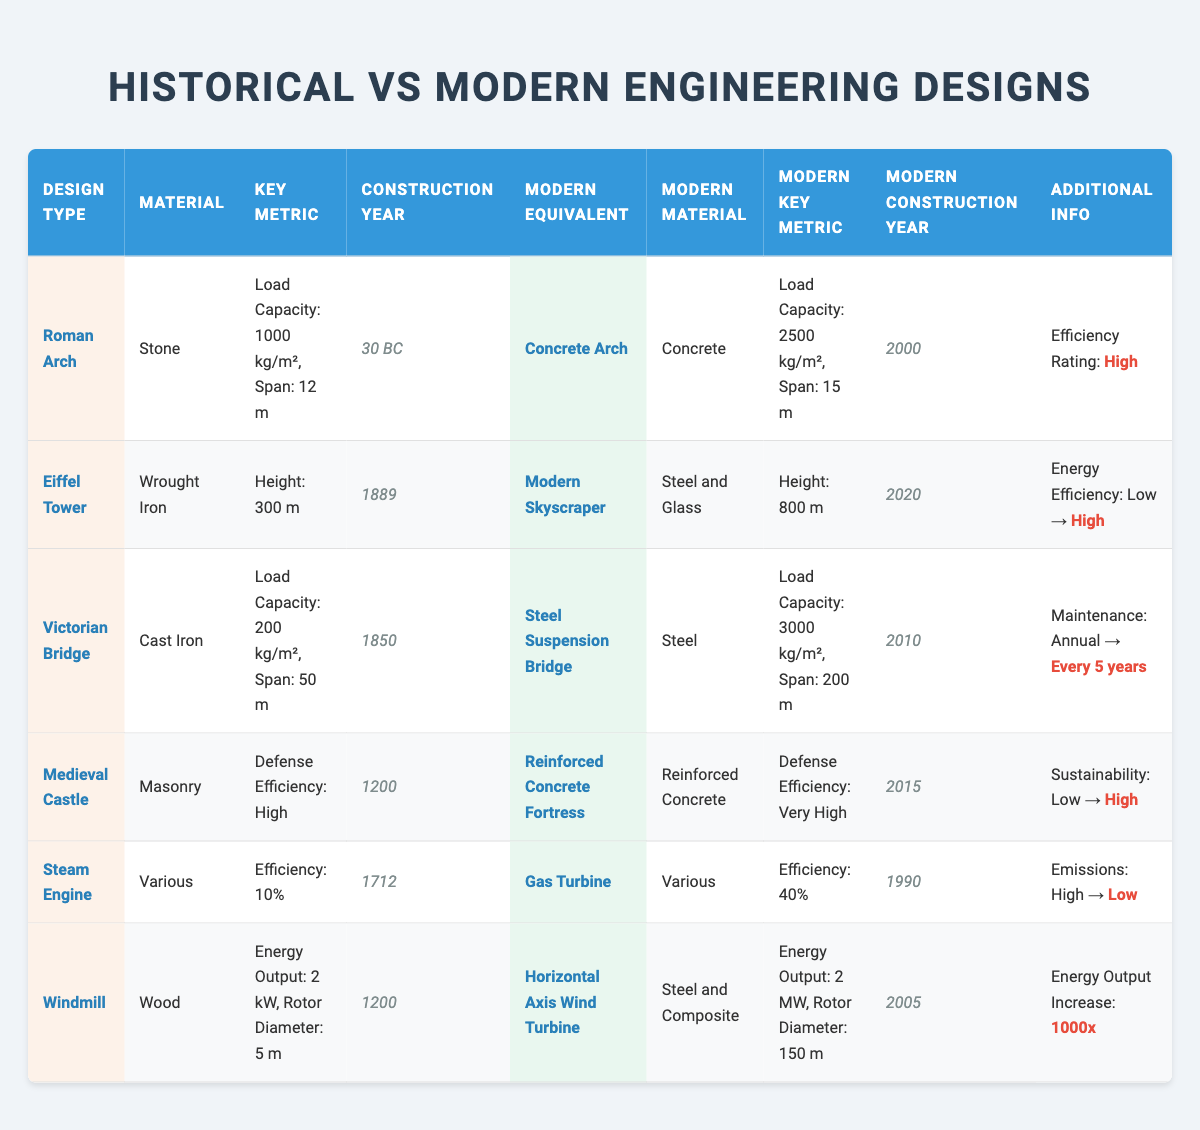What is the load capacity of the Victorian Bridge? The table states that the load capacity of the Victorian Bridge is 200 kg/m².
Answer: 200 kg/m² Which modern equivalent has the highest height? The modern equivalent of the Eiffel Tower, which is the Modern Skyscraper, has a height of 800 m, which is the highest compared to other modern equivalents in the table.
Answer: Modern Skyscraper at 800 m What is the increase in energy output from the Windmill to its modern equivalent? The Windmill's energy output is 2 kW and the modern equivalent, the Horizontal Axis Wind Turbine, has an output of 2 MW. Calculating the increase: 2 MW = 2000 kW, therefore the increase is 2000 kW - 2 kW = 1998 kW.
Answer: 1998 kW Is the defense efficiency of the Medieval Castle greater than that of the modern equivalent? The Medieval Castle has a defense efficiency of High, while the modern equivalent, the Reinforced Concrete Fortress, has a defense efficiency of Very High. Therefore, it is true that the modern equivalent has greater defense efficiency.
Answer: Yes How many years apart were the construction years of the Steam Engine and its modern equivalent? The Steam Engine was constructed in 1712 and its modern equivalent, the Gas Turbine, was constructed in 1990. To find the difference: 1990 - 1712 = 278 years apart.
Answer: 278 years What material is used for the construction of the Roman Arch? According to the table, the material used for the Roman Arch is Stone.
Answer: Stone Which modern equivalent has a better energy efficiency rating compared to its historical design? The Steam Engine has an efficiency of 10%, while the Gas Turbine has an efficiency of 40%. Since 40% is significantly better than 10%, it indicates that the modern equivalent has a better efficiency rating.
Answer: Gas Turbine What is the ratio of the load capacity of the Steel Suspension Bridge to that of the Victorian Bridge? The load capacity of the Steel Suspension Bridge is 3000 kg/m², and that of the Victorian Bridge is 200 kg/m². The ratio is 3000 / 200 = 15.
Answer: 15 When comparing sustainability ratings, does the modern equivalent of the Medieval Castle have a higher rating? The sustainability rating of the Medieval Castle is Low, while the modern equivalent, the Reinforced Concrete Fortress, has a sustainability rating of High. This indicates that the modern design has a higher sustainability rating.
Answer: Yes What is the percentage increase in load capacity from the Roman Arch to its modern equivalent? The Roman Arch's load capacity is 1000 kg/m² and the modern Concrete Arch's load capacity is 2500 kg/m². The increase is 2500 - 1000 = 1500 kg/m². To find the percentage increase: (1500 / 1000) x 100 = 150%.
Answer: 150% 